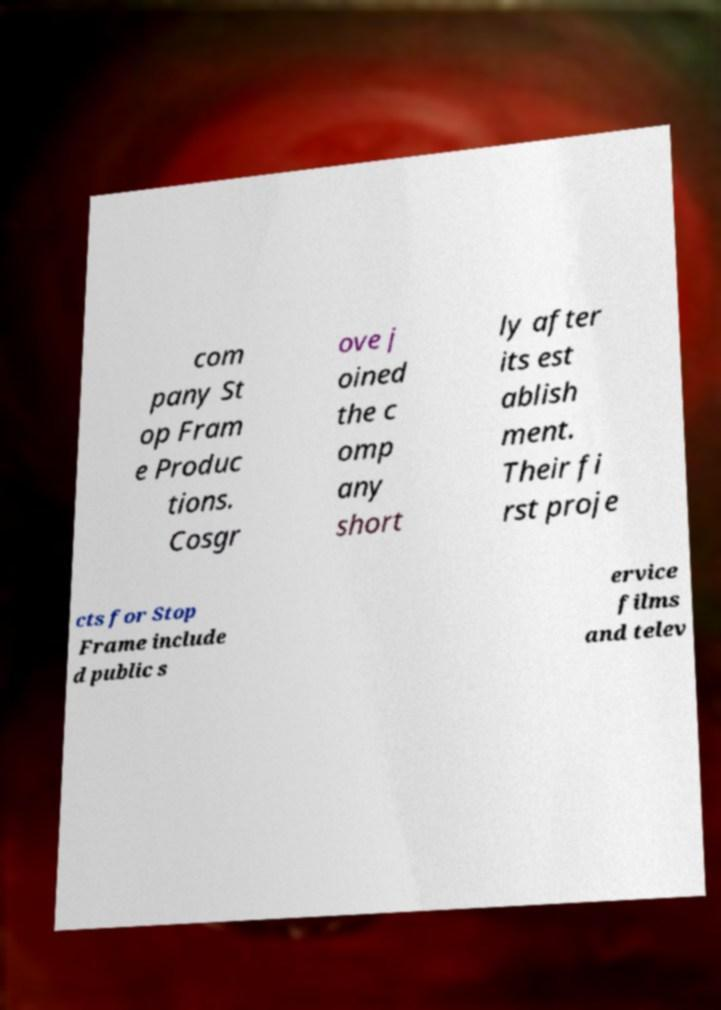Can you accurately transcribe the text from the provided image for me? com pany St op Fram e Produc tions. Cosgr ove j oined the c omp any short ly after its est ablish ment. Their fi rst proje cts for Stop Frame include d public s ervice films and telev 